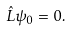<formula> <loc_0><loc_0><loc_500><loc_500>\hat { L } \psi _ { 0 } = 0 .</formula> 